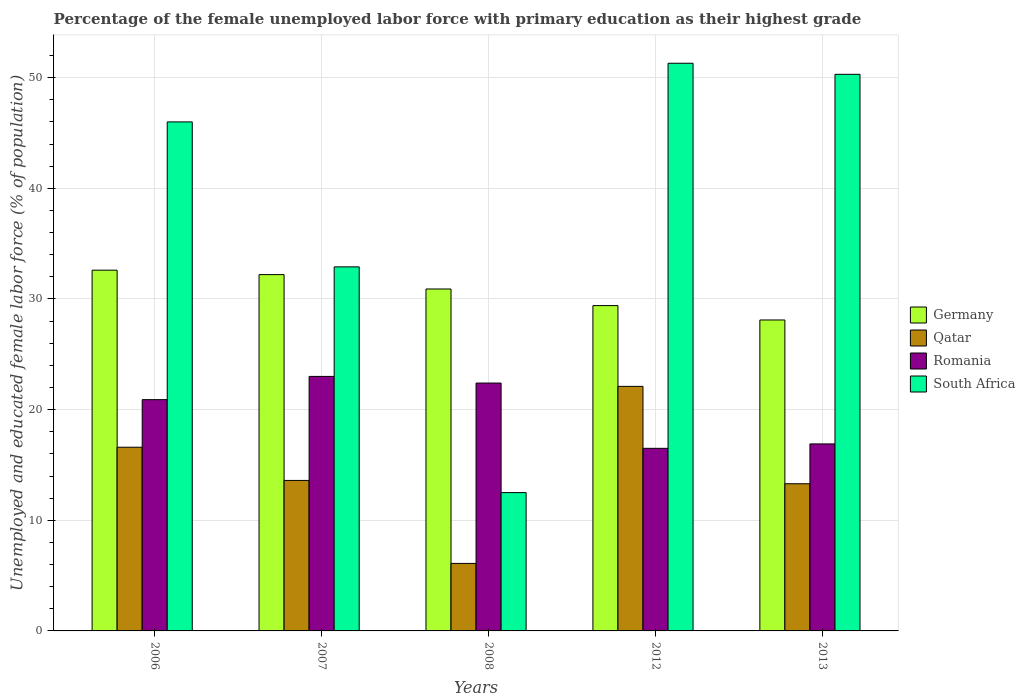How many bars are there on the 1st tick from the right?
Provide a short and direct response. 4. In how many cases, is the number of bars for a given year not equal to the number of legend labels?
Offer a terse response. 0. What is the percentage of the unemployed female labor force with primary education in Germany in 2012?
Give a very brief answer. 29.4. Across all years, what is the maximum percentage of the unemployed female labor force with primary education in South Africa?
Your answer should be compact. 51.3. Across all years, what is the minimum percentage of the unemployed female labor force with primary education in Germany?
Your answer should be very brief. 28.1. In which year was the percentage of the unemployed female labor force with primary education in Romania maximum?
Provide a short and direct response. 2007. In which year was the percentage of the unemployed female labor force with primary education in Germany minimum?
Your response must be concise. 2013. What is the total percentage of the unemployed female labor force with primary education in South Africa in the graph?
Offer a terse response. 193. What is the difference between the percentage of the unemployed female labor force with primary education in Romania in 2006 and that in 2013?
Provide a succinct answer. 4. What is the difference between the percentage of the unemployed female labor force with primary education in Germany in 2012 and the percentage of the unemployed female labor force with primary education in South Africa in 2006?
Make the answer very short. -16.6. What is the average percentage of the unemployed female labor force with primary education in South Africa per year?
Make the answer very short. 38.6. In the year 2013, what is the difference between the percentage of the unemployed female labor force with primary education in Germany and percentage of the unemployed female labor force with primary education in Romania?
Offer a very short reply. 11.2. In how many years, is the percentage of the unemployed female labor force with primary education in Qatar greater than 38 %?
Offer a terse response. 0. What is the ratio of the percentage of the unemployed female labor force with primary education in South Africa in 2008 to that in 2013?
Provide a short and direct response. 0.25. Is the percentage of the unemployed female labor force with primary education in Romania in 2006 less than that in 2007?
Give a very brief answer. Yes. What is the difference between the highest and the second highest percentage of the unemployed female labor force with primary education in Germany?
Provide a succinct answer. 0.4. What is the difference between the highest and the lowest percentage of the unemployed female labor force with primary education in Qatar?
Your response must be concise. 16. Is the sum of the percentage of the unemployed female labor force with primary education in Germany in 2007 and 2012 greater than the maximum percentage of the unemployed female labor force with primary education in Romania across all years?
Provide a short and direct response. Yes. Is it the case that in every year, the sum of the percentage of the unemployed female labor force with primary education in Germany and percentage of the unemployed female labor force with primary education in South Africa is greater than the sum of percentage of the unemployed female labor force with primary education in Qatar and percentage of the unemployed female labor force with primary education in Romania?
Give a very brief answer. Yes. What does the 1st bar from the right in 2008 represents?
Your response must be concise. South Africa. Is it the case that in every year, the sum of the percentage of the unemployed female labor force with primary education in South Africa and percentage of the unemployed female labor force with primary education in Qatar is greater than the percentage of the unemployed female labor force with primary education in Germany?
Your answer should be very brief. No. Does the graph contain any zero values?
Provide a short and direct response. No. Does the graph contain grids?
Keep it short and to the point. Yes. Where does the legend appear in the graph?
Offer a terse response. Center right. What is the title of the graph?
Your answer should be compact. Percentage of the female unemployed labor force with primary education as their highest grade. Does "Sweden" appear as one of the legend labels in the graph?
Your answer should be compact. No. What is the label or title of the X-axis?
Your response must be concise. Years. What is the label or title of the Y-axis?
Make the answer very short. Unemployed and educated female labor force (% of population). What is the Unemployed and educated female labor force (% of population) in Germany in 2006?
Ensure brevity in your answer.  32.6. What is the Unemployed and educated female labor force (% of population) in Qatar in 2006?
Offer a very short reply. 16.6. What is the Unemployed and educated female labor force (% of population) in Romania in 2006?
Your answer should be very brief. 20.9. What is the Unemployed and educated female labor force (% of population) of South Africa in 2006?
Your answer should be very brief. 46. What is the Unemployed and educated female labor force (% of population) of Germany in 2007?
Keep it short and to the point. 32.2. What is the Unemployed and educated female labor force (% of population) of Qatar in 2007?
Provide a succinct answer. 13.6. What is the Unemployed and educated female labor force (% of population) in South Africa in 2007?
Offer a very short reply. 32.9. What is the Unemployed and educated female labor force (% of population) in Germany in 2008?
Your answer should be compact. 30.9. What is the Unemployed and educated female labor force (% of population) in Qatar in 2008?
Give a very brief answer. 6.1. What is the Unemployed and educated female labor force (% of population) of Romania in 2008?
Give a very brief answer. 22.4. What is the Unemployed and educated female labor force (% of population) in Germany in 2012?
Your answer should be compact. 29.4. What is the Unemployed and educated female labor force (% of population) in Qatar in 2012?
Your answer should be compact. 22.1. What is the Unemployed and educated female labor force (% of population) in South Africa in 2012?
Provide a short and direct response. 51.3. What is the Unemployed and educated female labor force (% of population) in Germany in 2013?
Your answer should be very brief. 28.1. What is the Unemployed and educated female labor force (% of population) of Qatar in 2013?
Keep it short and to the point. 13.3. What is the Unemployed and educated female labor force (% of population) of Romania in 2013?
Your answer should be compact. 16.9. What is the Unemployed and educated female labor force (% of population) in South Africa in 2013?
Make the answer very short. 50.3. Across all years, what is the maximum Unemployed and educated female labor force (% of population) in Germany?
Offer a very short reply. 32.6. Across all years, what is the maximum Unemployed and educated female labor force (% of population) of Qatar?
Your answer should be compact. 22.1. Across all years, what is the maximum Unemployed and educated female labor force (% of population) of South Africa?
Your response must be concise. 51.3. Across all years, what is the minimum Unemployed and educated female labor force (% of population) of Germany?
Ensure brevity in your answer.  28.1. Across all years, what is the minimum Unemployed and educated female labor force (% of population) in Qatar?
Ensure brevity in your answer.  6.1. Across all years, what is the minimum Unemployed and educated female labor force (% of population) in Romania?
Give a very brief answer. 16.5. What is the total Unemployed and educated female labor force (% of population) in Germany in the graph?
Offer a terse response. 153.2. What is the total Unemployed and educated female labor force (% of population) in Qatar in the graph?
Provide a succinct answer. 71.7. What is the total Unemployed and educated female labor force (% of population) of Romania in the graph?
Offer a very short reply. 99.7. What is the total Unemployed and educated female labor force (% of population) in South Africa in the graph?
Keep it short and to the point. 193. What is the difference between the Unemployed and educated female labor force (% of population) in Germany in 2006 and that in 2007?
Your answer should be very brief. 0.4. What is the difference between the Unemployed and educated female labor force (% of population) in Qatar in 2006 and that in 2007?
Keep it short and to the point. 3. What is the difference between the Unemployed and educated female labor force (% of population) of Romania in 2006 and that in 2007?
Provide a short and direct response. -2.1. What is the difference between the Unemployed and educated female labor force (% of population) of South Africa in 2006 and that in 2007?
Ensure brevity in your answer.  13.1. What is the difference between the Unemployed and educated female labor force (% of population) in Qatar in 2006 and that in 2008?
Your answer should be very brief. 10.5. What is the difference between the Unemployed and educated female labor force (% of population) of South Africa in 2006 and that in 2008?
Keep it short and to the point. 33.5. What is the difference between the Unemployed and educated female labor force (% of population) of Romania in 2006 and that in 2012?
Your answer should be very brief. 4.4. What is the difference between the Unemployed and educated female labor force (% of population) of Qatar in 2006 and that in 2013?
Offer a very short reply. 3.3. What is the difference between the Unemployed and educated female labor force (% of population) of Romania in 2006 and that in 2013?
Give a very brief answer. 4. What is the difference between the Unemployed and educated female labor force (% of population) of South Africa in 2006 and that in 2013?
Provide a succinct answer. -4.3. What is the difference between the Unemployed and educated female labor force (% of population) of Germany in 2007 and that in 2008?
Your response must be concise. 1.3. What is the difference between the Unemployed and educated female labor force (% of population) of South Africa in 2007 and that in 2008?
Offer a terse response. 20.4. What is the difference between the Unemployed and educated female labor force (% of population) in Germany in 2007 and that in 2012?
Your answer should be very brief. 2.8. What is the difference between the Unemployed and educated female labor force (% of population) in Romania in 2007 and that in 2012?
Offer a very short reply. 6.5. What is the difference between the Unemployed and educated female labor force (% of population) of South Africa in 2007 and that in 2012?
Provide a short and direct response. -18.4. What is the difference between the Unemployed and educated female labor force (% of population) in Qatar in 2007 and that in 2013?
Offer a very short reply. 0.3. What is the difference between the Unemployed and educated female labor force (% of population) in South Africa in 2007 and that in 2013?
Keep it short and to the point. -17.4. What is the difference between the Unemployed and educated female labor force (% of population) in South Africa in 2008 and that in 2012?
Provide a short and direct response. -38.8. What is the difference between the Unemployed and educated female labor force (% of population) in Qatar in 2008 and that in 2013?
Provide a short and direct response. -7.2. What is the difference between the Unemployed and educated female labor force (% of population) in Romania in 2008 and that in 2013?
Provide a succinct answer. 5.5. What is the difference between the Unemployed and educated female labor force (% of population) of South Africa in 2008 and that in 2013?
Give a very brief answer. -37.8. What is the difference between the Unemployed and educated female labor force (% of population) in Qatar in 2012 and that in 2013?
Provide a succinct answer. 8.8. What is the difference between the Unemployed and educated female labor force (% of population) in Romania in 2012 and that in 2013?
Give a very brief answer. -0.4. What is the difference between the Unemployed and educated female labor force (% of population) of South Africa in 2012 and that in 2013?
Keep it short and to the point. 1. What is the difference between the Unemployed and educated female labor force (% of population) in Germany in 2006 and the Unemployed and educated female labor force (% of population) in Qatar in 2007?
Provide a short and direct response. 19. What is the difference between the Unemployed and educated female labor force (% of population) in Germany in 2006 and the Unemployed and educated female labor force (% of population) in South Africa in 2007?
Ensure brevity in your answer.  -0.3. What is the difference between the Unemployed and educated female labor force (% of population) in Qatar in 2006 and the Unemployed and educated female labor force (% of population) in Romania in 2007?
Ensure brevity in your answer.  -6.4. What is the difference between the Unemployed and educated female labor force (% of population) in Qatar in 2006 and the Unemployed and educated female labor force (% of population) in South Africa in 2007?
Offer a terse response. -16.3. What is the difference between the Unemployed and educated female labor force (% of population) of Romania in 2006 and the Unemployed and educated female labor force (% of population) of South Africa in 2007?
Your answer should be compact. -12. What is the difference between the Unemployed and educated female labor force (% of population) in Germany in 2006 and the Unemployed and educated female labor force (% of population) in Qatar in 2008?
Give a very brief answer. 26.5. What is the difference between the Unemployed and educated female labor force (% of population) in Germany in 2006 and the Unemployed and educated female labor force (% of population) in Romania in 2008?
Offer a very short reply. 10.2. What is the difference between the Unemployed and educated female labor force (% of population) in Germany in 2006 and the Unemployed and educated female labor force (% of population) in South Africa in 2008?
Give a very brief answer. 20.1. What is the difference between the Unemployed and educated female labor force (% of population) in Germany in 2006 and the Unemployed and educated female labor force (% of population) in Qatar in 2012?
Offer a very short reply. 10.5. What is the difference between the Unemployed and educated female labor force (% of population) in Germany in 2006 and the Unemployed and educated female labor force (% of population) in Romania in 2012?
Your answer should be compact. 16.1. What is the difference between the Unemployed and educated female labor force (% of population) of Germany in 2006 and the Unemployed and educated female labor force (% of population) of South Africa in 2012?
Give a very brief answer. -18.7. What is the difference between the Unemployed and educated female labor force (% of population) in Qatar in 2006 and the Unemployed and educated female labor force (% of population) in South Africa in 2012?
Ensure brevity in your answer.  -34.7. What is the difference between the Unemployed and educated female labor force (% of population) of Romania in 2006 and the Unemployed and educated female labor force (% of population) of South Africa in 2012?
Make the answer very short. -30.4. What is the difference between the Unemployed and educated female labor force (% of population) of Germany in 2006 and the Unemployed and educated female labor force (% of population) of Qatar in 2013?
Offer a terse response. 19.3. What is the difference between the Unemployed and educated female labor force (% of population) in Germany in 2006 and the Unemployed and educated female labor force (% of population) in South Africa in 2013?
Provide a short and direct response. -17.7. What is the difference between the Unemployed and educated female labor force (% of population) in Qatar in 2006 and the Unemployed and educated female labor force (% of population) in South Africa in 2013?
Provide a succinct answer. -33.7. What is the difference between the Unemployed and educated female labor force (% of population) in Romania in 2006 and the Unemployed and educated female labor force (% of population) in South Africa in 2013?
Your answer should be compact. -29.4. What is the difference between the Unemployed and educated female labor force (% of population) of Germany in 2007 and the Unemployed and educated female labor force (% of population) of Qatar in 2008?
Your answer should be compact. 26.1. What is the difference between the Unemployed and educated female labor force (% of population) in Germany in 2007 and the Unemployed and educated female labor force (% of population) in Romania in 2008?
Your answer should be very brief. 9.8. What is the difference between the Unemployed and educated female labor force (% of population) of Germany in 2007 and the Unemployed and educated female labor force (% of population) of South Africa in 2008?
Offer a terse response. 19.7. What is the difference between the Unemployed and educated female labor force (% of population) in Qatar in 2007 and the Unemployed and educated female labor force (% of population) in Romania in 2008?
Your answer should be compact. -8.8. What is the difference between the Unemployed and educated female labor force (% of population) of Qatar in 2007 and the Unemployed and educated female labor force (% of population) of South Africa in 2008?
Offer a very short reply. 1.1. What is the difference between the Unemployed and educated female labor force (% of population) in Germany in 2007 and the Unemployed and educated female labor force (% of population) in South Africa in 2012?
Provide a short and direct response. -19.1. What is the difference between the Unemployed and educated female labor force (% of population) of Qatar in 2007 and the Unemployed and educated female labor force (% of population) of South Africa in 2012?
Offer a terse response. -37.7. What is the difference between the Unemployed and educated female labor force (% of population) of Romania in 2007 and the Unemployed and educated female labor force (% of population) of South Africa in 2012?
Your answer should be very brief. -28.3. What is the difference between the Unemployed and educated female labor force (% of population) of Germany in 2007 and the Unemployed and educated female labor force (% of population) of Qatar in 2013?
Provide a short and direct response. 18.9. What is the difference between the Unemployed and educated female labor force (% of population) of Germany in 2007 and the Unemployed and educated female labor force (% of population) of South Africa in 2013?
Provide a short and direct response. -18.1. What is the difference between the Unemployed and educated female labor force (% of population) of Qatar in 2007 and the Unemployed and educated female labor force (% of population) of South Africa in 2013?
Keep it short and to the point. -36.7. What is the difference between the Unemployed and educated female labor force (% of population) of Romania in 2007 and the Unemployed and educated female labor force (% of population) of South Africa in 2013?
Offer a terse response. -27.3. What is the difference between the Unemployed and educated female labor force (% of population) of Germany in 2008 and the Unemployed and educated female labor force (% of population) of Romania in 2012?
Make the answer very short. 14.4. What is the difference between the Unemployed and educated female labor force (% of population) in Germany in 2008 and the Unemployed and educated female labor force (% of population) in South Africa in 2012?
Ensure brevity in your answer.  -20.4. What is the difference between the Unemployed and educated female labor force (% of population) in Qatar in 2008 and the Unemployed and educated female labor force (% of population) in South Africa in 2012?
Your answer should be very brief. -45.2. What is the difference between the Unemployed and educated female labor force (% of population) in Romania in 2008 and the Unemployed and educated female labor force (% of population) in South Africa in 2012?
Your response must be concise. -28.9. What is the difference between the Unemployed and educated female labor force (% of population) of Germany in 2008 and the Unemployed and educated female labor force (% of population) of South Africa in 2013?
Give a very brief answer. -19.4. What is the difference between the Unemployed and educated female labor force (% of population) in Qatar in 2008 and the Unemployed and educated female labor force (% of population) in South Africa in 2013?
Your answer should be compact. -44.2. What is the difference between the Unemployed and educated female labor force (% of population) in Romania in 2008 and the Unemployed and educated female labor force (% of population) in South Africa in 2013?
Offer a very short reply. -27.9. What is the difference between the Unemployed and educated female labor force (% of population) in Germany in 2012 and the Unemployed and educated female labor force (% of population) in South Africa in 2013?
Make the answer very short. -20.9. What is the difference between the Unemployed and educated female labor force (% of population) in Qatar in 2012 and the Unemployed and educated female labor force (% of population) in Romania in 2013?
Ensure brevity in your answer.  5.2. What is the difference between the Unemployed and educated female labor force (% of population) of Qatar in 2012 and the Unemployed and educated female labor force (% of population) of South Africa in 2013?
Provide a succinct answer. -28.2. What is the difference between the Unemployed and educated female labor force (% of population) in Romania in 2012 and the Unemployed and educated female labor force (% of population) in South Africa in 2013?
Make the answer very short. -33.8. What is the average Unemployed and educated female labor force (% of population) in Germany per year?
Provide a short and direct response. 30.64. What is the average Unemployed and educated female labor force (% of population) of Qatar per year?
Your answer should be compact. 14.34. What is the average Unemployed and educated female labor force (% of population) of Romania per year?
Make the answer very short. 19.94. What is the average Unemployed and educated female labor force (% of population) of South Africa per year?
Give a very brief answer. 38.6. In the year 2006, what is the difference between the Unemployed and educated female labor force (% of population) of Germany and Unemployed and educated female labor force (% of population) of Romania?
Your answer should be compact. 11.7. In the year 2006, what is the difference between the Unemployed and educated female labor force (% of population) in Germany and Unemployed and educated female labor force (% of population) in South Africa?
Give a very brief answer. -13.4. In the year 2006, what is the difference between the Unemployed and educated female labor force (% of population) in Qatar and Unemployed and educated female labor force (% of population) in South Africa?
Ensure brevity in your answer.  -29.4. In the year 2006, what is the difference between the Unemployed and educated female labor force (% of population) of Romania and Unemployed and educated female labor force (% of population) of South Africa?
Make the answer very short. -25.1. In the year 2007, what is the difference between the Unemployed and educated female labor force (% of population) of Germany and Unemployed and educated female labor force (% of population) of Romania?
Ensure brevity in your answer.  9.2. In the year 2007, what is the difference between the Unemployed and educated female labor force (% of population) in Qatar and Unemployed and educated female labor force (% of population) in Romania?
Keep it short and to the point. -9.4. In the year 2007, what is the difference between the Unemployed and educated female labor force (% of population) in Qatar and Unemployed and educated female labor force (% of population) in South Africa?
Keep it short and to the point. -19.3. In the year 2007, what is the difference between the Unemployed and educated female labor force (% of population) of Romania and Unemployed and educated female labor force (% of population) of South Africa?
Provide a short and direct response. -9.9. In the year 2008, what is the difference between the Unemployed and educated female labor force (% of population) in Germany and Unemployed and educated female labor force (% of population) in Qatar?
Your answer should be compact. 24.8. In the year 2008, what is the difference between the Unemployed and educated female labor force (% of population) in Qatar and Unemployed and educated female labor force (% of population) in Romania?
Provide a short and direct response. -16.3. In the year 2008, what is the difference between the Unemployed and educated female labor force (% of population) in Qatar and Unemployed and educated female labor force (% of population) in South Africa?
Provide a short and direct response. -6.4. In the year 2008, what is the difference between the Unemployed and educated female labor force (% of population) in Romania and Unemployed and educated female labor force (% of population) in South Africa?
Provide a short and direct response. 9.9. In the year 2012, what is the difference between the Unemployed and educated female labor force (% of population) in Germany and Unemployed and educated female labor force (% of population) in Qatar?
Offer a terse response. 7.3. In the year 2012, what is the difference between the Unemployed and educated female labor force (% of population) in Germany and Unemployed and educated female labor force (% of population) in South Africa?
Offer a terse response. -21.9. In the year 2012, what is the difference between the Unemployed and educated female labor force (% of population) of Qatar and Unemployed and educated female labor force (% of population) of South Africa?
Give a very brief answer. -29.2. In the year 2012, what is the difference between the Unemployed and educated female labor force (% of population) of Romania and Unemployed and educated female labor force (% of population) of South Africa?
Your response must be concise. -34.8. In the year 2013, what is the difference between the Unemployed and educated female labor force (% of population) in Germany and Unemployed and educated female labor force (% of population) in Romania?
Your answer should be compact. 11.2. In the year 2013, what is the difference between the Unemployed and educated female labor force (% of population) of Germany and Unemployed and educated female labor force (% of population) of South Africa?
Offer a terse response. -22.2. In the year 2013, what is the difference between the Unemployed and educated female labor force (% of population) in Qatar and Unemployed and educated female labor force (% of population) in South Africa?
Provide a succinct answer. -37. In the year 2013, what is the difference between the Unemployed and educated female labor force (% of population) in Romania and Unemployed and educated female labor force (% of population) in South Africa?
Give a very brief answer. -33.4. What is the ratio of the Unemployed and educated female labor force (% of population) of Germany in 2006 to that in 2007?
Provide a short and direct response. 1.01. What is the ratio of the Unemployed and educated female labor force (% of population) in Qatar in 2006 to that in 2007?
Your answer should be very brief. 1.22. What is the ratio of the Unemployed and educated female labor force (% of population) in Romania in 2006 to that in 2007?
Ensure brevity in your answer.  0.91. What is the ratio of the Unemployed and educated female labor force (% of population) of South Africa in 2006 to that in 2007?
Your answer should be compact. 1.4. What is the ratio of the Unemployed and educated female labor force (% of population) in Germany in 2006 to that in 2008?
Keep it short and to the point. 1.05. What is the ratio of the Unemployed and educated female labor force (% of population) in Qatar in 2006 to that in 2008?
Ensure brevity in your answer.  2.72. What is the ratio of the Unemployed and educated female labor force (% of population) of Romania in 2006 to that in 2008?
Offer a very short reply. 0.93. What is the ratio of the Unemployed and educated female labor force (% of population) of South Africa in 2006 to that in 2008?
Offer a very short reply. 3.68. What is the ratio of the Unemployed and educated female labor force (% of population) in Germany in 2006 to that in 2012?
Your answer should be very brief. 1.11. What is the ratio of the Unemployed and educated female labor force (% of population) of Qatar in 2006 to that in 2012?
Your answer should be very brief. 0.75. What is the ratio of the Unemployed and educated female labor force (% of population) of Romania in 2006 to that in 2012?
Your answer should be compact. 1.27. What is the ratio of the Unemployed and educated female labor force (% of population) in South Africa in 2006 to that in 2012?
Provide a succinct answer. 0.9. What is the ratio of the Unemployed and educated female labor force (% of population) in Germany in 2006 to that in 2013?
Make the answer very short. 1.16. What is the ratio of the Unemployed and educated female labor force (% of population) in Qatar in 2006 to that in 2013?
Your answer should be compact. 1.25. What is the ratio of the Unemployed and educated female labor force (% of population) of Romania in 2006 to that in 2013?
Your answer should be compact. 1.24. What is the ratio of the Unemployed and educated female labor force (% of population) of South Africa in 2006 to that in 2013?
Your answer should be compact. 0.91. What is the ratio of the Unemployed and educated female labor force (% of population) in Germany in 2007 to that in 2008?
Keep it short and to the point. 1.04. What is the ratio of the Unemployed and educated female labor force (% of population) of Qatar in 2007 to that in 2008?
Offer a very short reply. 2.23. What is the ratio of the Unemployed and educated female labor force (% of population) in Romania in 2007 to that in 2008?
Your answer should be very brief. 1.03. What is the ratio of the Unemployed and educated female labor force (% of population) of South Africa in 2007 to that in 2008?
Provide a succinct answer. 2.63. What is the ratio of the Unemployed and educated female labor force (% of population) of Germany in 2007 to that in 2012?
Offer a terse response. 1.1. What is the ratio of the Unemployed and educated female labor force (% of population) of Qatar in 2007 to that in 2012?
Provide a succinct answer. 0.62. What is the ratio of the Unemployed and educated female labor force (% of population) in Romania in 2007 to that in 2012?
Your answer should be compact. 1.39. What is the ratio of the Unemployed and educated female labor force (% of population) in South Africa in 2007 to that in 2012?
Your response must be concise. 0.64. What is the ratio of the Unemployed and educated female labor force (% of population) in Germany in 2007 to that in 2013?
Your answer should be compact. 1.15. What is the ratio of the Unemployed and educated female labor force (% of population) of Qatar in 2007 to that in 2013?
Your answer should be very brief. 1.02. What is the ratio of the Unemployed and educated female labor force (% of population) of Romania in 2007 to that in 2013?
Your response must be concise. 1.36. What is the ratio of the Unemployed and educated female labor force (% of population) of South Africa in 2007 to that in 2013?
Your answer should be very brief. 0.65. What is the ratio of the Unemployed and educated female labor force (% of population) in Germany in 2008 to that in 2012?
Keep it short and to the point. 1.05. What is the ratio of the Unemployed and educated female labor force (% of population) in Qatar in 2008 to that in 2012?
Your response must be concise. 0.28. What is the ratio of the Unemployed and educated female labor force (% of population) in Romania in 2008 to that in 2012?
Provide a short and direct response. 1.36. What is the ratio of the Unemployed and educated female labor force (% of population) in South Africa in 2008 to that in 2012?
Offer a terse response. 0.24. What is the ratio of the Unemployed and educated female labor force (% of population) of Germany in 2008 to that in 2013?
Your response must be concise. 1.1. What is the ratio of the Unemployed and educated female labor force (% of population) in Qatar in 2008 to that in 2013?
Ensure brevity in your answer.  0.46. What is the ratio of the Unemployed and educated female labor force (% of population) in Romania in 2008 to that in 2013?
Provide a succinct answer. 1.33. What is the ratio of the Unemployed and educated female labor force (% of population) of South Africa in 2008 to that in 2013?
Your answer should be compact. 0.25. What is the ratio of the Unemployed and educated female labor force (% of population) of Germany in 2012 to that in 2013?
Your answer should be very brief. 1.05. What is the ratio of the Unemployed and educated female labor force (% of population) in Qatar in 2012 to that in 2013?
Make the answer very short. 1.66. What is the ratio of the Unemployed and educated female labor force (% of population) in Romania in 2012 to that in 2013?
Your answer should be very brief. 0.98. What is the ratio of the Unemployed and educated female labor force (% of population) of South Africa in 2012 to that in 2013?
Your response must be concise. 1.02. What is the difference between the highest and the second highest Unemployed and educated female labor force (% of population) in South Africa?
Your answer should be very brief. 1. What is the difference between the highest and the lowest Unemployed and educated female labor force (% of population) of Germany?
Provide a short and direct response. 4.5. What is the difference between the highest and the lowest Unemployed and educated female labor force (% of population) in South Africa?
Keep it short and to the point. 38.8. 